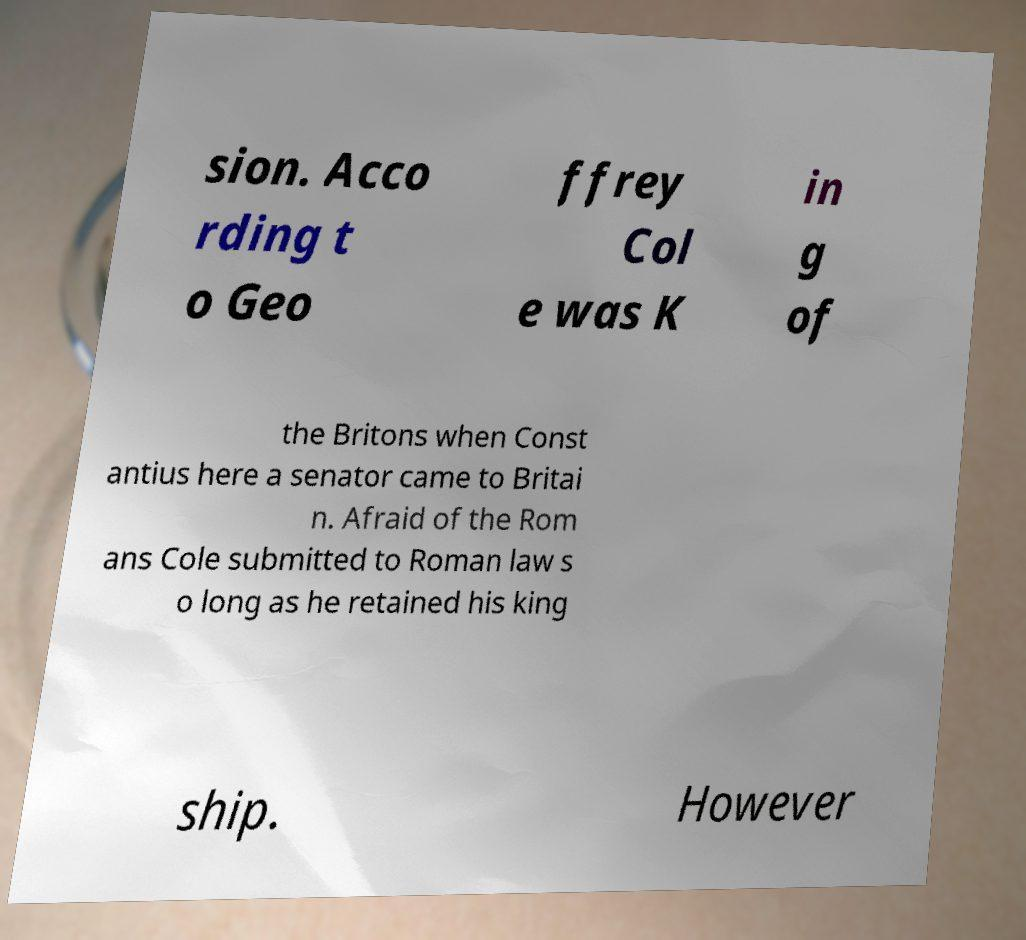For documentation purposes, I need the text within this image transcribed. Could you provide that? sion. Acco rding t o Geo ffrey Col e was K in g of the Britons when Const antius here a senator came to Britai n. Afraid of the Rom ans Cole submitted to Roman law s o long as he retained his king ship. However 